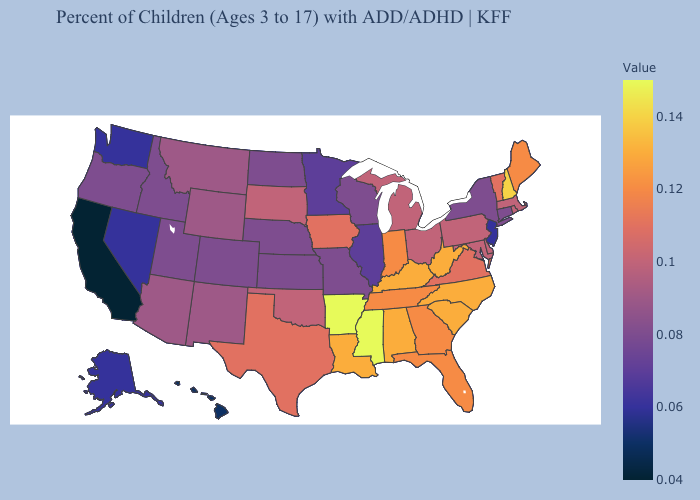Does Arkansas have the highest value in the USA?
Keep it brief. Yes. Which states have the lowest value in the USA?
Give a very brief answer. California. Does Utah have the highest value in the West?
Concise answer only. No. Among the states that border New Hampshire , does Vermont have the highest value?
Be succinct. No. Among the states that border Oklahoma , does Arkansas have the highest value?
Keep it brief. Yes. 